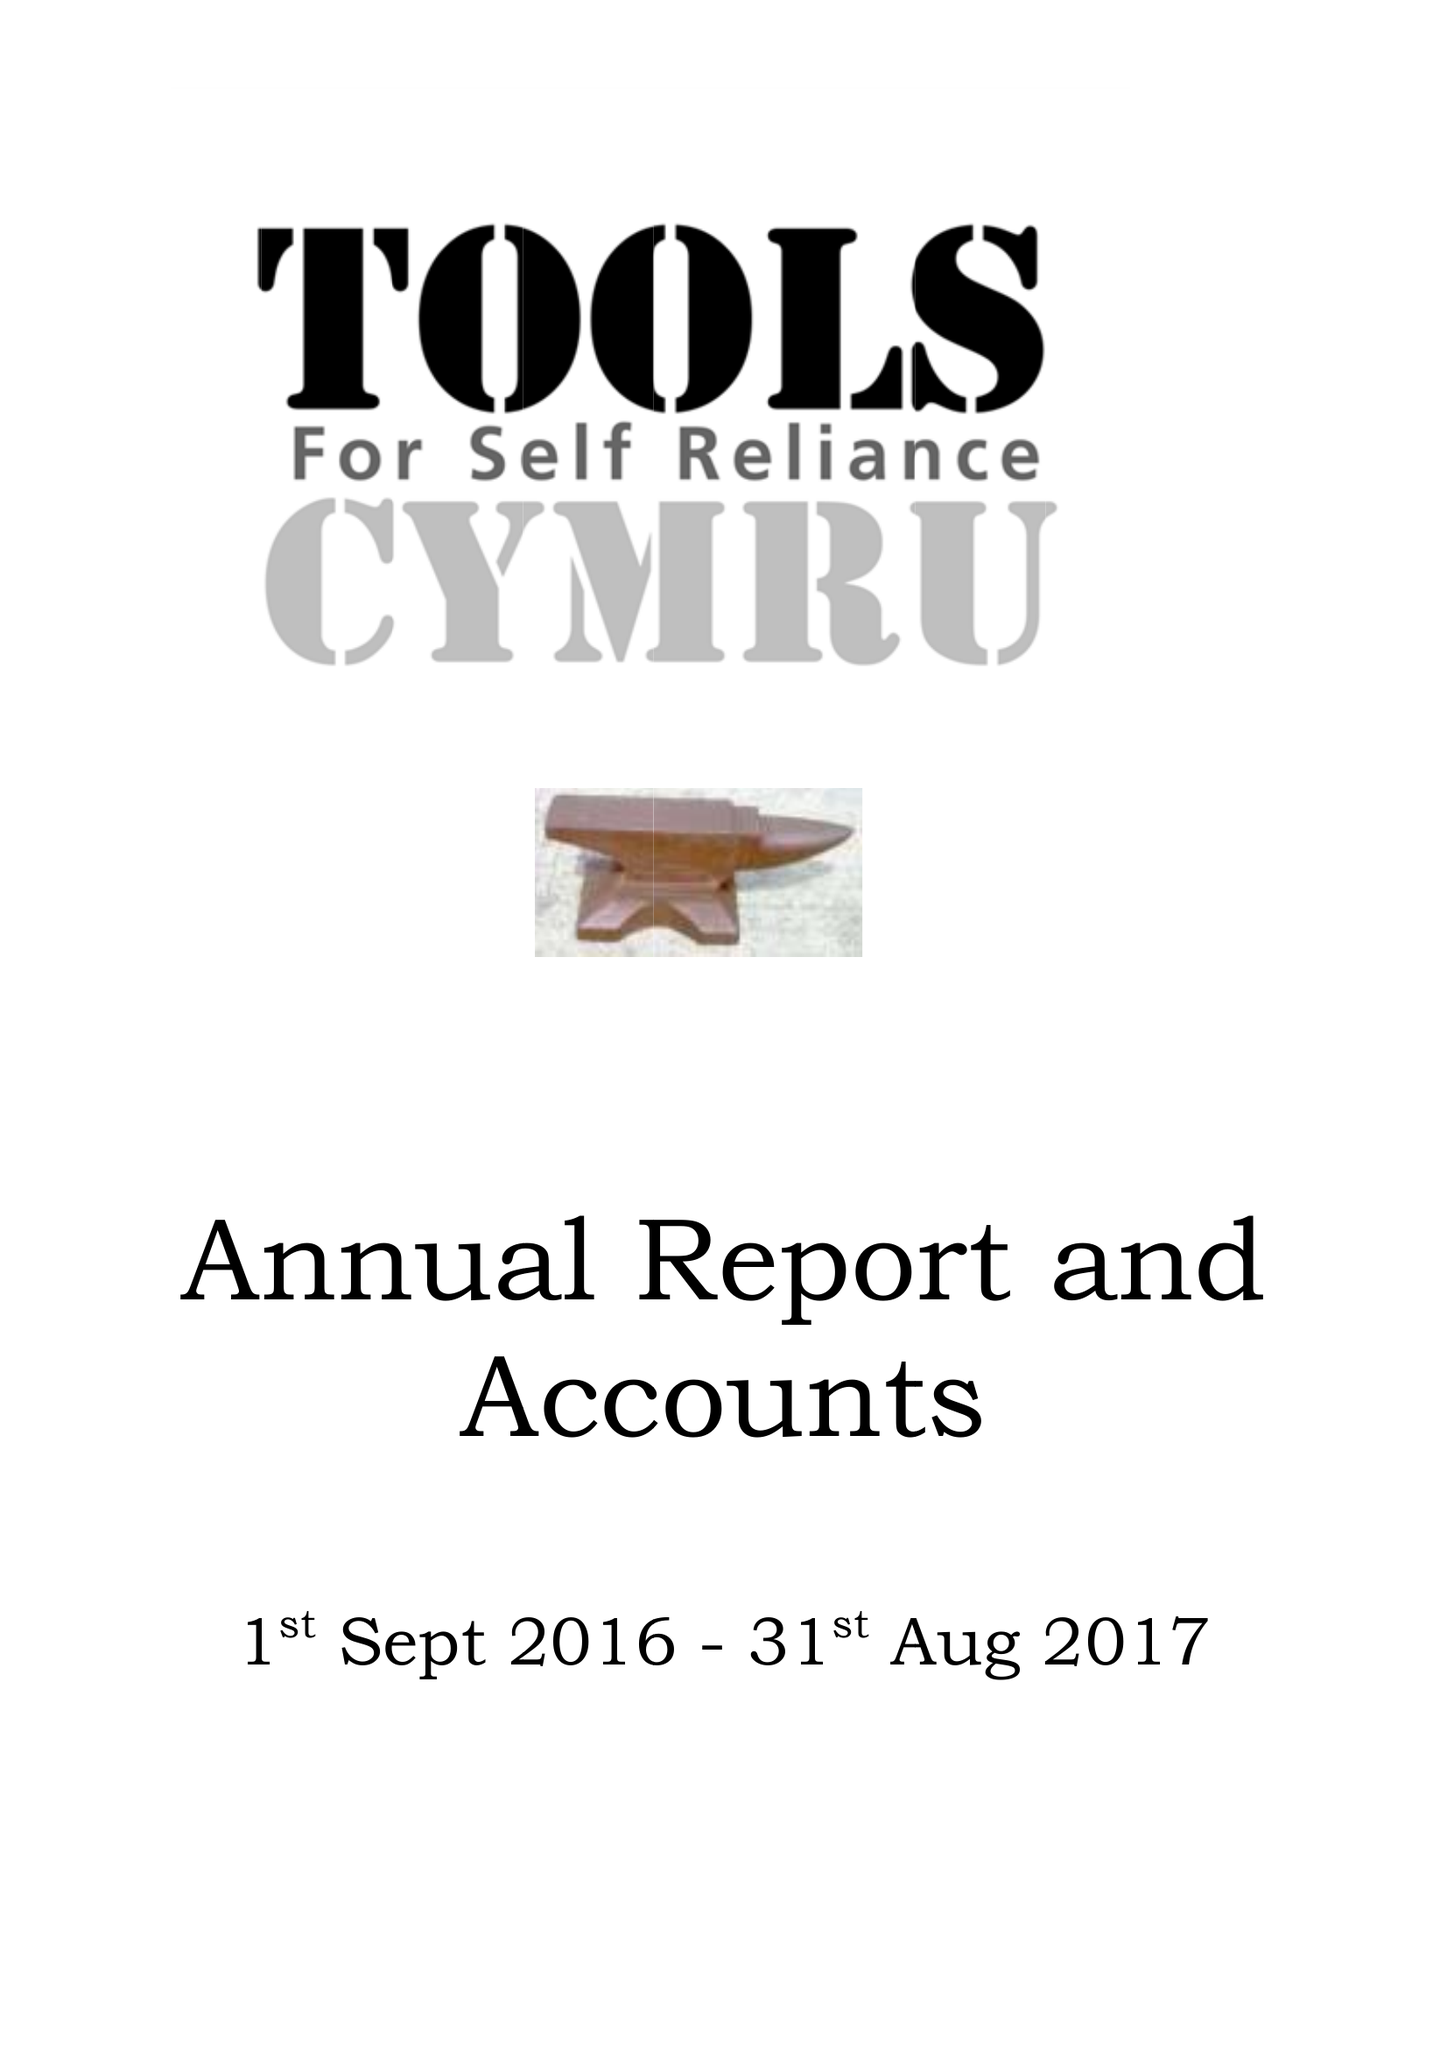What is the value for the charity_number?
Answer the question using a single word or phrase. 1055483 